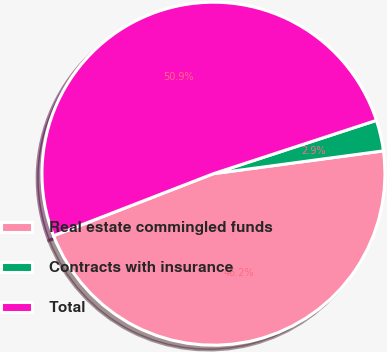Convert chart. <chart><loc_0><loc_0><loc_500><loc_500><pie_chart><fcel>Real estate commingled funds<fcel>Contracts with insurance<fcel>Total<nl><fcel>46.23%<fcel>2.91%<fcel>50.86%<nl></chart> 